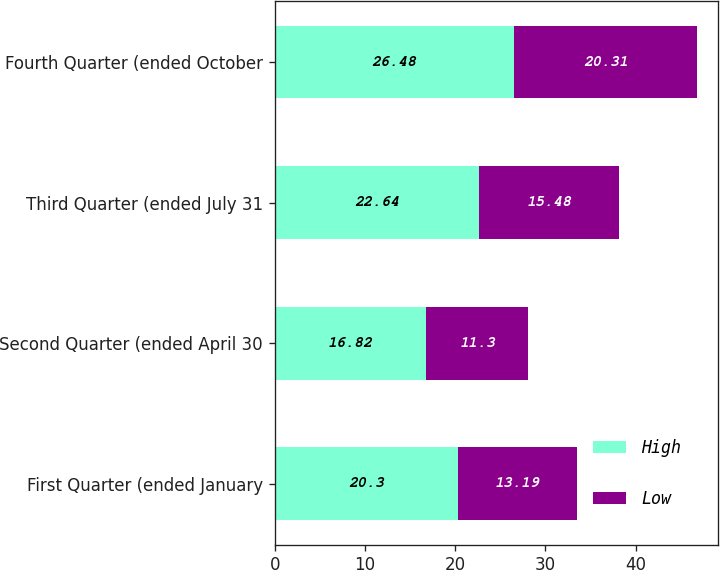Convert chart to OTSL. <chart><loc_0><loc_0><loc_500><loc_500><stacked_bar_chart><ecel><fcel>First Quarter (ended January<fcel>Second Quarter (ended April 30<fcel>Third Quarter (ended July 31<fcel>Fourth Quarter (ended October<nl><fcel>High<fcel>20.3<fcel>16.82<fcel>22.64<fcel>26.48<nl><fcel>Low<fcel>13.19<fcel>11.3<fcel>15.48<fcel>20.31<nl></chart> 